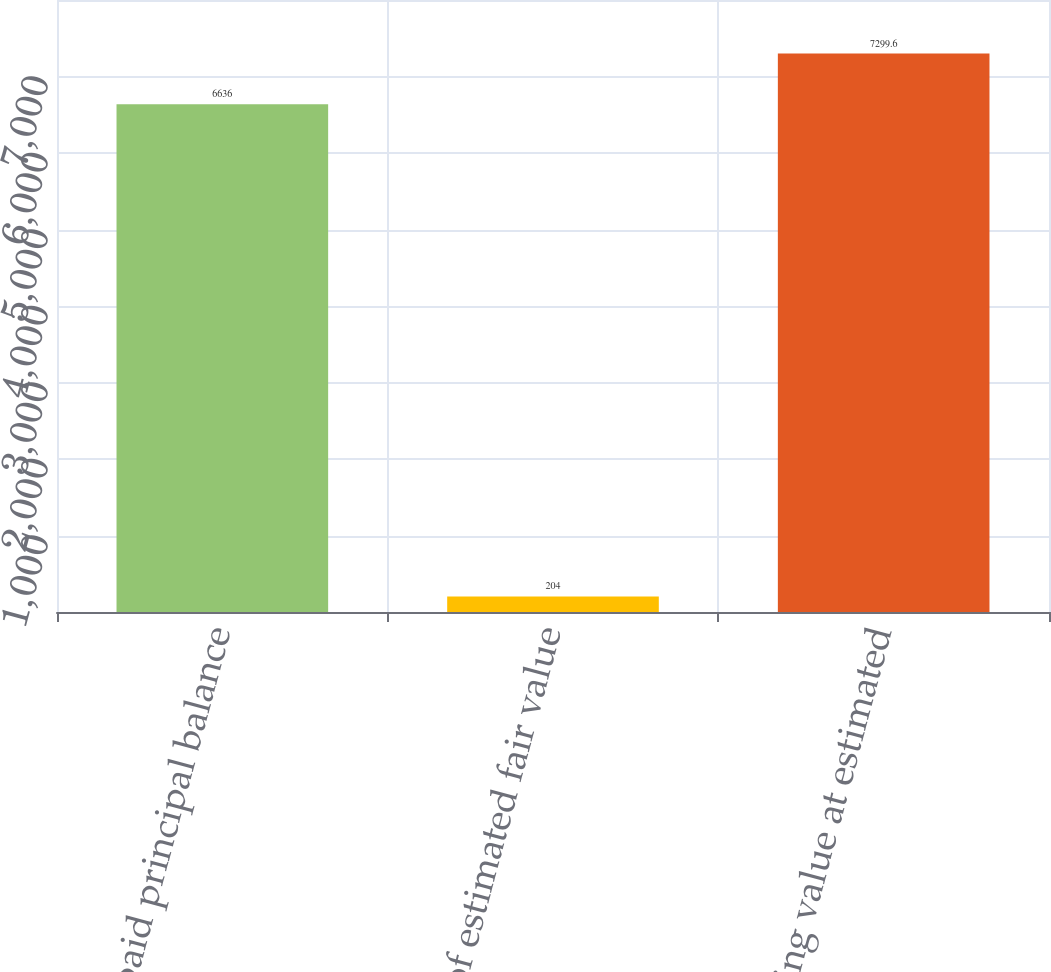<chart> <loc_0><loc_0><loc_500><loc_500><bar_chart><fcel>Unpaid principal balance<fcel>Excess of estimated fair value<fcel>Carrying value at estimated<nl><fcel>6636<fcel>204<fcel>7299.6<nl></chart> 